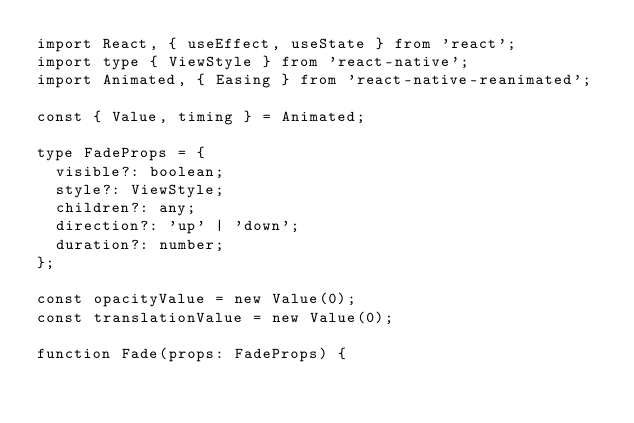Convert code to text. <code><loc_0><loc_0><loc_500><loc_500><_TypeScript_>import React, { useEffect, useState } from 'react';
import type { ViewStyle } from 'react-native';
import Animated, { Easing } from 'react-native-reanimated';

const { Value, timing } = Animated;

type FadeProps = {
  visible?: boolean;
  style?: ViewStyle;
  children?: any;
  direction?: 'up' | 'down';
  duration?: number;
};

const opacityValue = new Value(0);
const translationValue = new Value(0);

function Fade(props: FadeProps) {</code> 